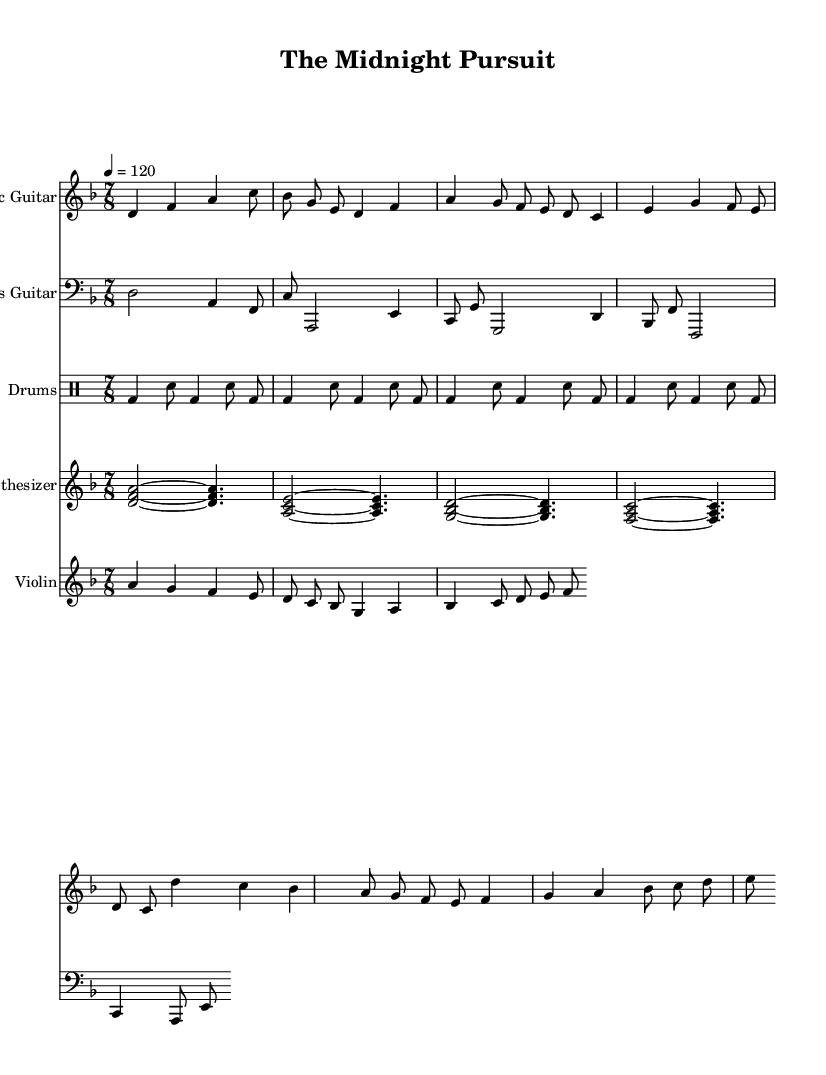What is the key signature of this music? The key signature is determined by looking at the beginning of the staff where the sharps or flats are indicated. In this case, there are no sharps or flats, which identifies it as the D minor key signature.
Answer: D minor What is the time signature of the piece? The time signature is shown at the beginning of the score, consisting of two numbers. Here, the top number is 7 and the bottom number is 8, indicating that there are seven beats in a measure, with eighth notes receiving one beat each.
Answer: 7/8 What is the tempo marking for the piece? The tempo marking can be found in the score before the first measure. It is indicated by the beat per minute (BPM). Here, it is noted as 120 BPM, meaning there are 120 beats per minute in this composition.
Answer: 120 How many instruments are featured in this score? To determine the number of instruments, we can count the distinct staff sections or parts indicated in the score. There are five different staffs, each representing a different instrument: electric guitar, bass guitar, drums, synthesizer, and violin.
Answer: Five Which instrument plays the highest notes in this score? We identify the instrument playing the highest notes by reviewing the range of notes in each staff. The synthesizer part shows chords that contain notes well above the other instrumental ranges, reaching a higher pitch than the others.
Answer: Synthesizer What is the rhythmic pattern for the drums? The rhythmic pattern can be understood by analyzing the drum notation in the score. The notation alternates between bass drum and snare hits in a consistent pattern across the measures, distinguishing a driving beat typical in progressive rock.
Answer: Alternating bass and snare What is the narrative theme suggested by the instrumentation? The combination of electric guitar riffs, synthesizer soundscapes, and the driving rhythm of drums are often associated with complex, atmospheric storytelling, especially in progressive rock. With hints of tension in the violin melodies, it suggests a theme centered around suspense, possibly related to a crime narrative.
Answer: Suspenseful storytelling 